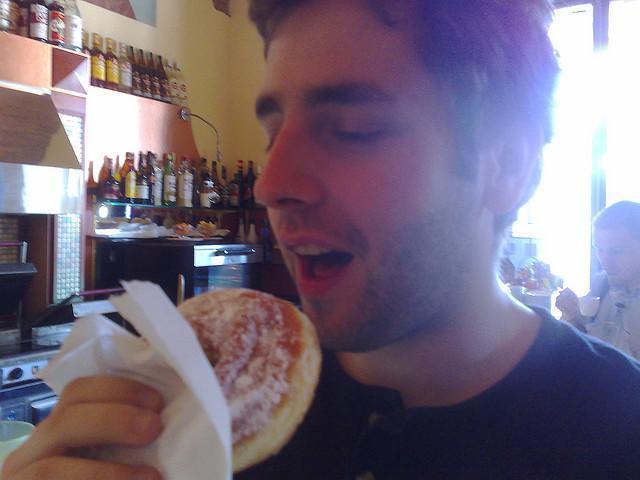How was the item prepared that is about to be bitten?
Answer the question by selecting the correct answer among the 4 following choices and explain your choice with a short sentence. The answer should be formatted with the following format: `Answer: choice
Rationale: rationale.`
Options: Deep fried, broiled, its raw, baked. Answer: deep fried.
Rationale: The man is eating a doughnut, and doughnuts are fried in order to make the dough consumable by customers. 